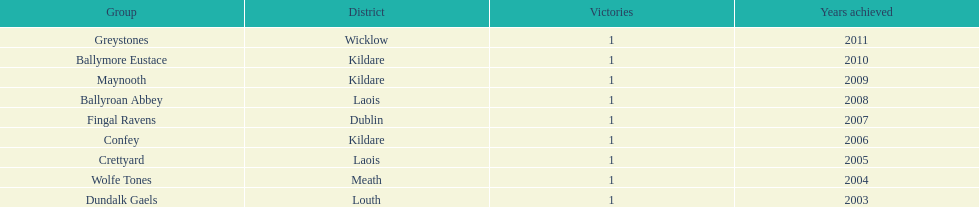Which team won previous to crettyard? Wolfe Tones. 